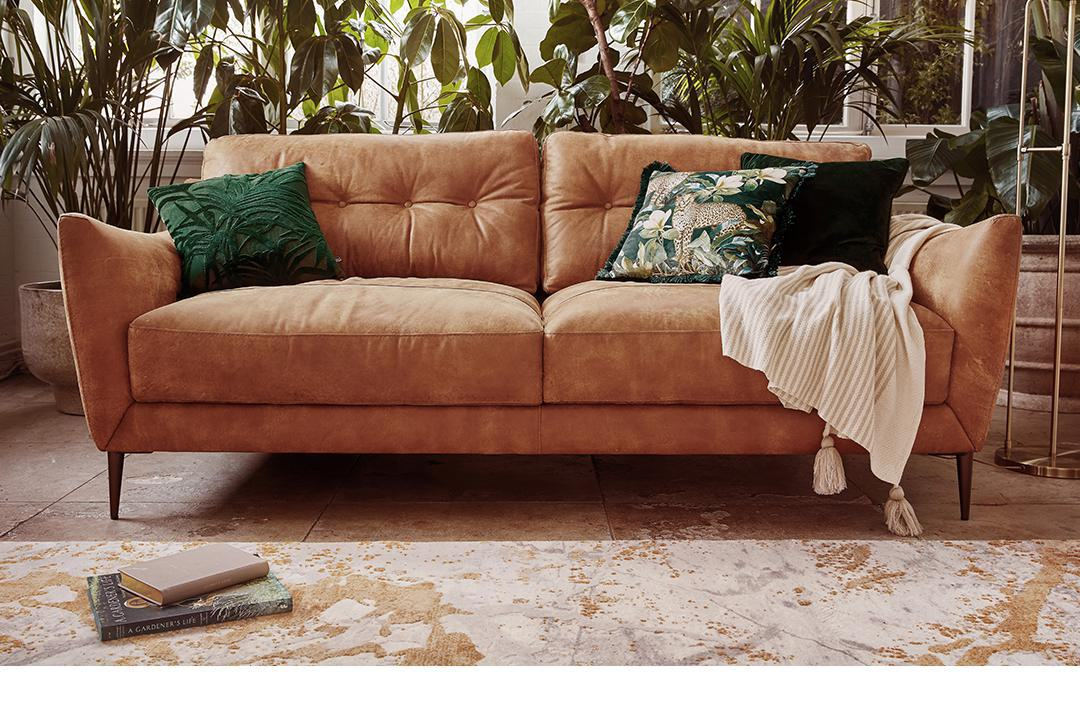Can you describe the lighting in the space? Although the actual light sources are not visible, the room appears to be bathed in soft, natural light, which suggests that there are windows or a glass door nearby. The gentle lighting accentuates the inviting warmth of the space. 